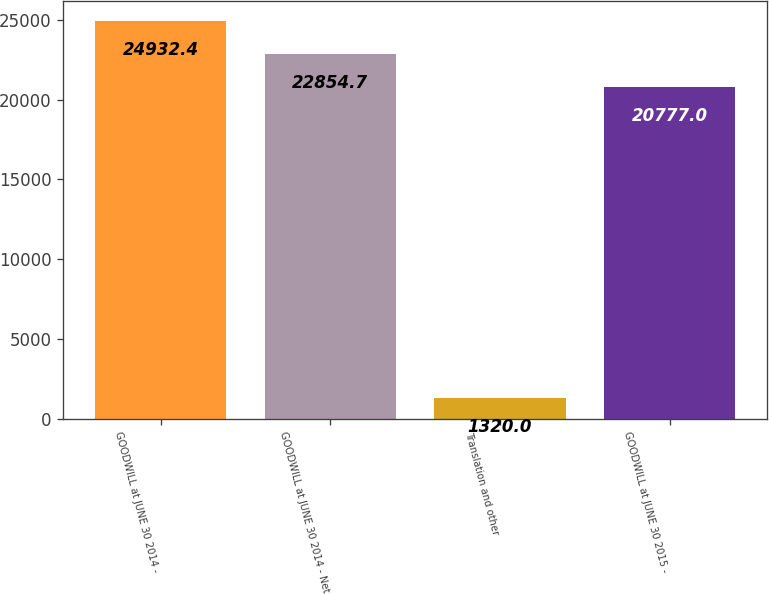<chart> <loc_0><loc_0><loc_500><loc_500><bar_chart><fcel>GOODWILL at JUNE 30 2014 -<fcel>GOODWILL at JUNE 30 2014 - Net<fcel>Translation and other<fcel>GOODWILL at JUNE 30 2015 -<nl><fcel>24932.4<fcel>22854.7<fcel>1320<fcel>20777<nl></chart> 